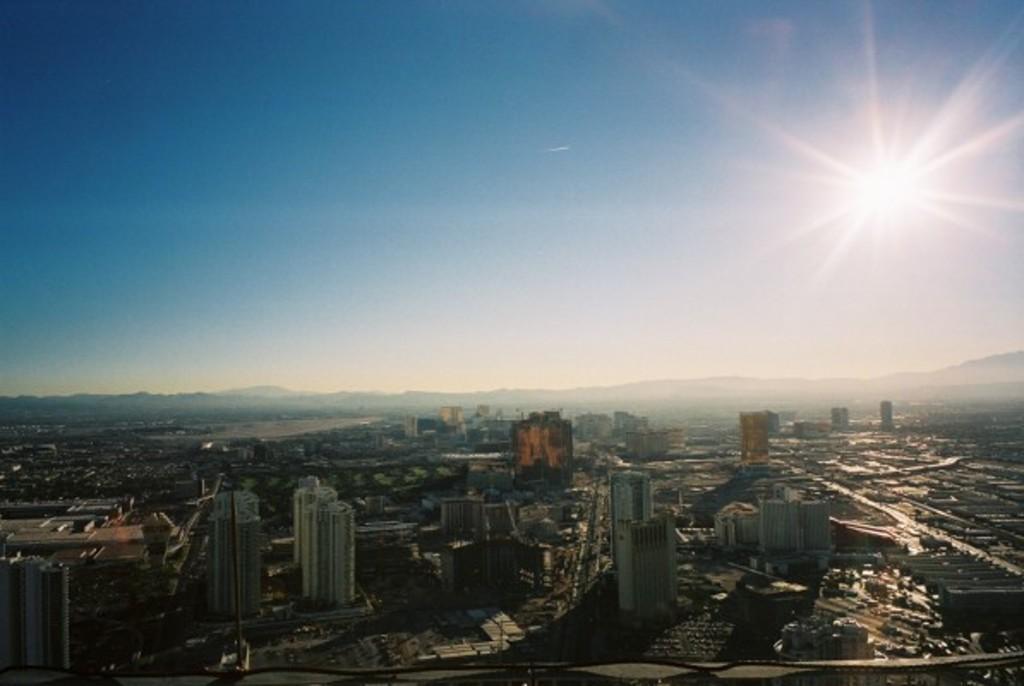What type of structures can be seen in the image? There are buildings in the image. What natural feature is visible in the background of the image? There are mountains in the background of the image. What celestial body is visible in the sky at the top of the image? The sun is visible in the sky at the top of the image. Can you hear the sheep singing a song while swimming in the image? There are no sheep, song, or swimming activity present in the image. 